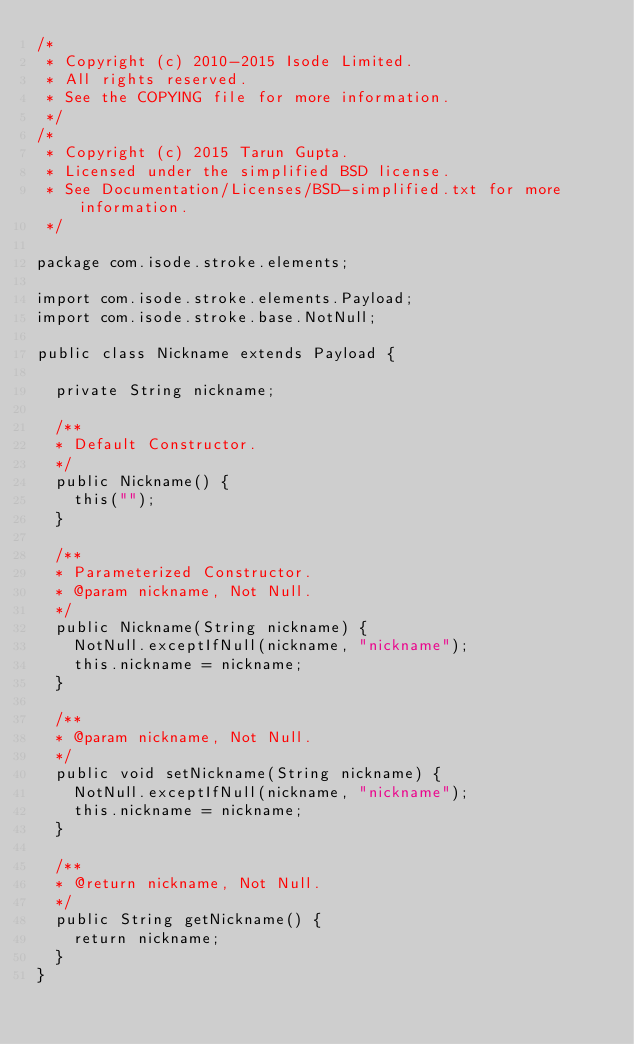Convert code to text. <code><loc_0><loc_0><loc_500><loc_500><_Java_>/*
 * Copyright (c) 2010-2015 Isode Limited.
 * All rights reserved.
 * See the COPYING file for more information.
 */
/*
 * Copyright (c) 2015 Tarun Gupta.
 * Licensed under the simplified BSD license.
 * See Documentation/Licenses/BSD-simplified.txt for more information.
 */

package com.isode.stroke.elements;

import com.isode.stroke.elements.Payload;
import com.isode.stroke.base.NotNull;

public class Nickname extends Payload {

	private String nickname;

	/**
	* Default Constructor.
	*/
	public Nickname() {
		this("");
	}

	/**
	* Parameterized Constructor.
	* @param nickname, Not Null.
	*/
	public Nickname(String nickname) {
		NotNull.exceptIfNull(nickname, "nickname");
		this.nickname = nickname;
	}

	/**
	* @param nickname, Not Null.
	*/
	public void setNickname(String nickname) {
		NotNull.exceptIfNull(nickname, "nickname");
		this.nickname = nickname;
	}

	/**
	* @return nickname, Not Null.
	*/
	public String getNickname() {
		return nickname;
	}
}</code> 